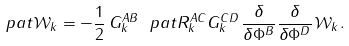<formula> <loc_0><loc_0><loc_500><loc_500>\ p a t \mathcal { W } _ { k } = - \frac { 1 } { 2 } \, G _ { k } ^ { A B } \ p a t R _ { k } ^ { A C } G _ { k } ^ { C D } \, \frac { \delta } { \delta \Phi ^ { B } } \frac { \delta } { \delta \Phi ^ { D } } \, \mathcal { W } _ { k } .</formula> 